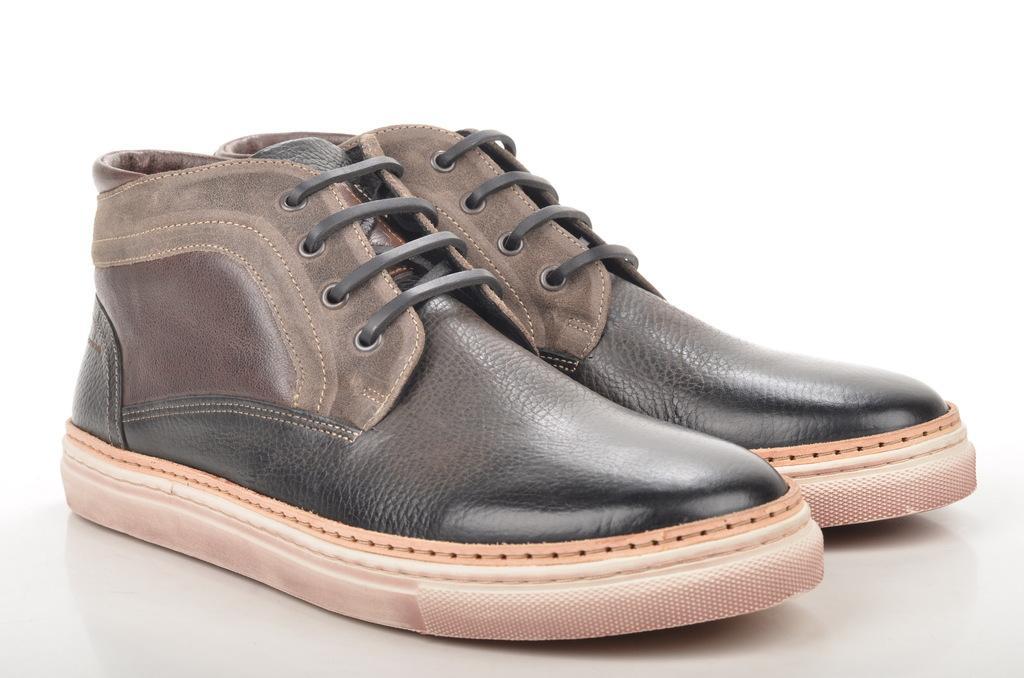What objects are in the image? There are shoes in the image. Where are the shoes placed? The shoes are on a white platform. What color is the platform? The platform is white. What is the color of the background in the image? The background of the image is white. What type of grain is being harvested in the image? There is: There is no grain or harvesting activity present in the image; it features shoes on a white platform with a white background. 